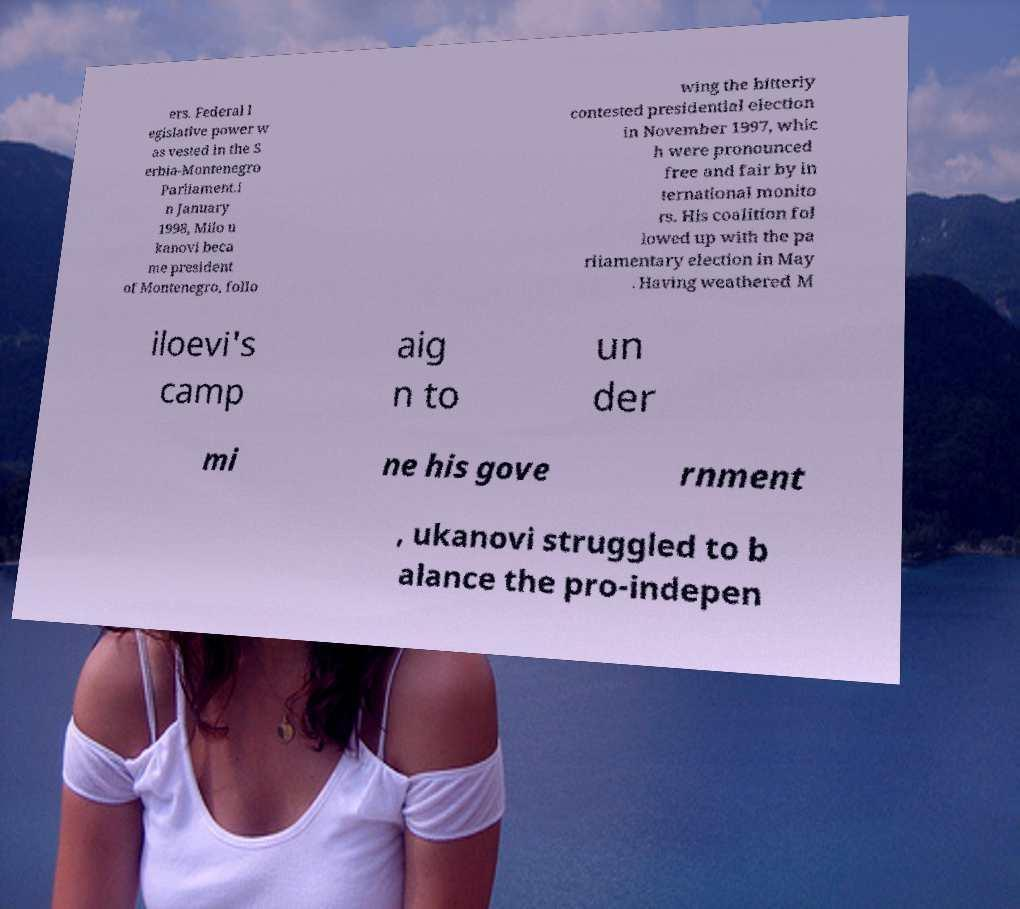Could you assist in decoding the text presented in this image and type it out clearly? ers. Federal l egislative power w as vested in the S erbia-Montenegro Parliament.I n January 1998, Milo u kanovi beca me president of Montenegro, follo wing the bitterly contested presidential election in November 1997, whic h were pronounced free and fair by in ternational monito rs. His coalition fol lowed up with the pa rliamentary election in May . Having weathered M iloevi's camp aig n to un der mi ne his gove rnment , ukanovi struggled to b alance the pro-indepen 